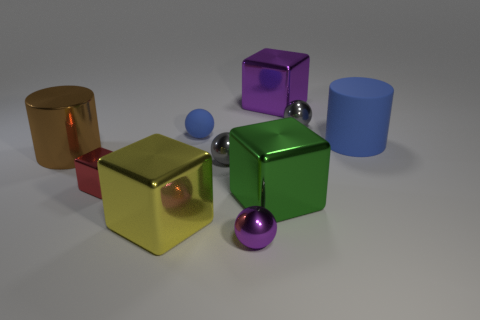Subtract all cubes. How many objects are left? 6 Subtract 0 cyan cylinders. How many objects are left? 10 Subtract all tiny red objects. Subtract all tiny red metallic cubes. How many objects are left? 8 Add 5 metal cylinders. How many metal cylinders are left? 6 Add 6 purple objects. How many purple objects exist? 8 